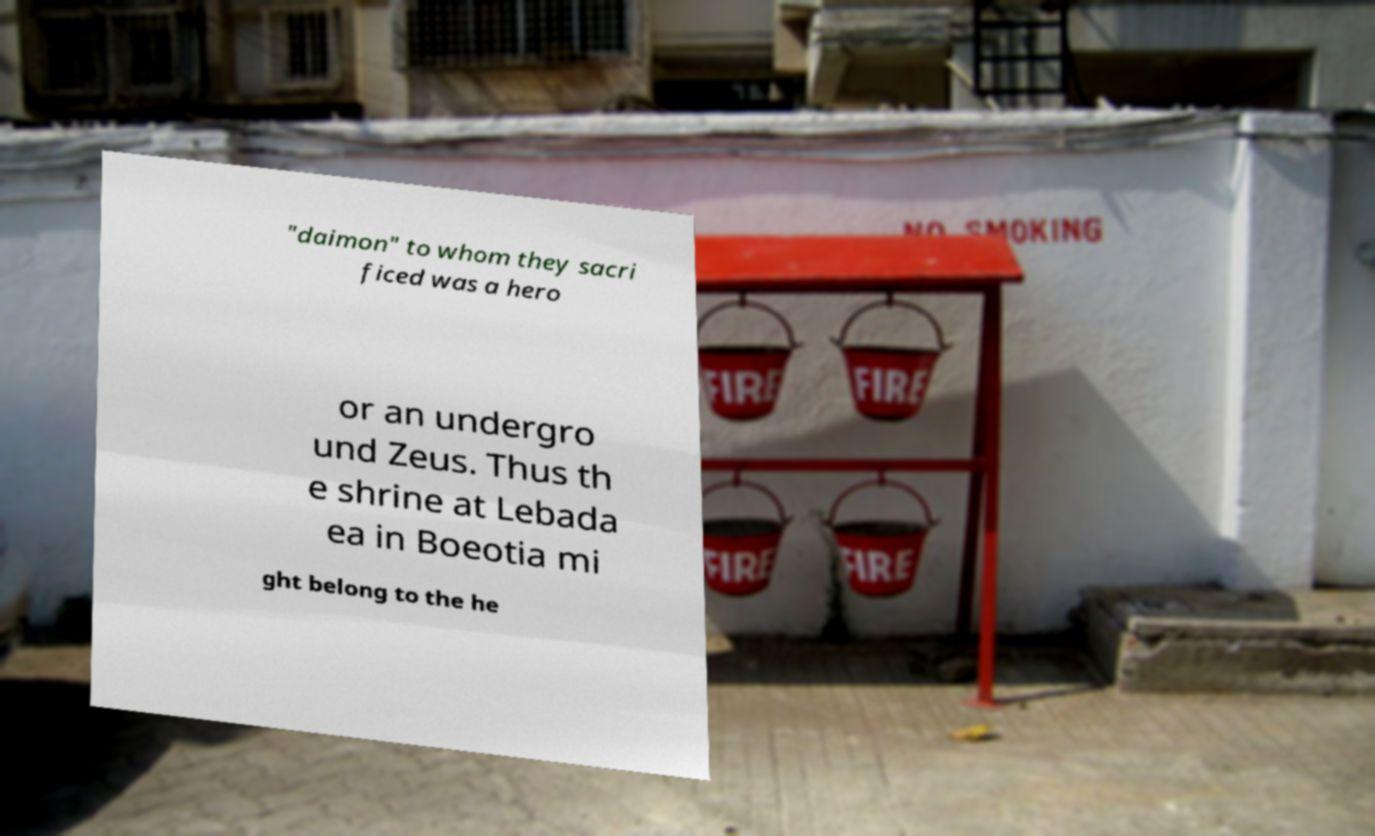I need the written content from this picture converted into text. Can you do that? "daimon" to whom they sacri ficed was a hero or an undergro und Zeus. Thus th e shrine at Lebada ea in Boeotia mi ght belong to the he 